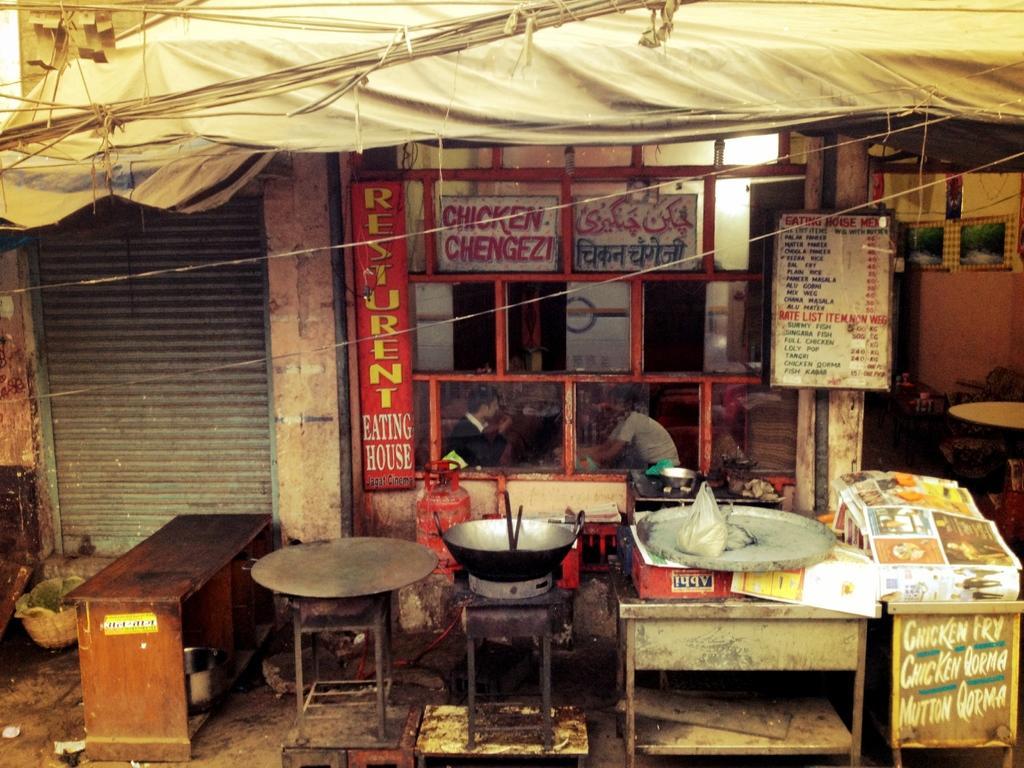How would you summarize this image in a sentence or two? In this picture, we see a bench, pan which is placed on stove and a wooden stool on which a plate is placed. Behind that, we see a board on which restaurant is written on it and on right corner of the picture, we see a board on which many items are displayed. On top of picture, we see a white tent. 